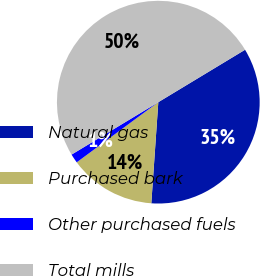Convert chart. <chart><loc_0><loc_0><loc_500><loc_500><pie_chart><fcel>Natural gas<fcel>Purchased bark<fcel>Other purchased fuels<fcel>Total mills<nl><fcel>34.75%<fcel>13.79%<fcel>1.46%<fcel>50.0%<nl></chart> 